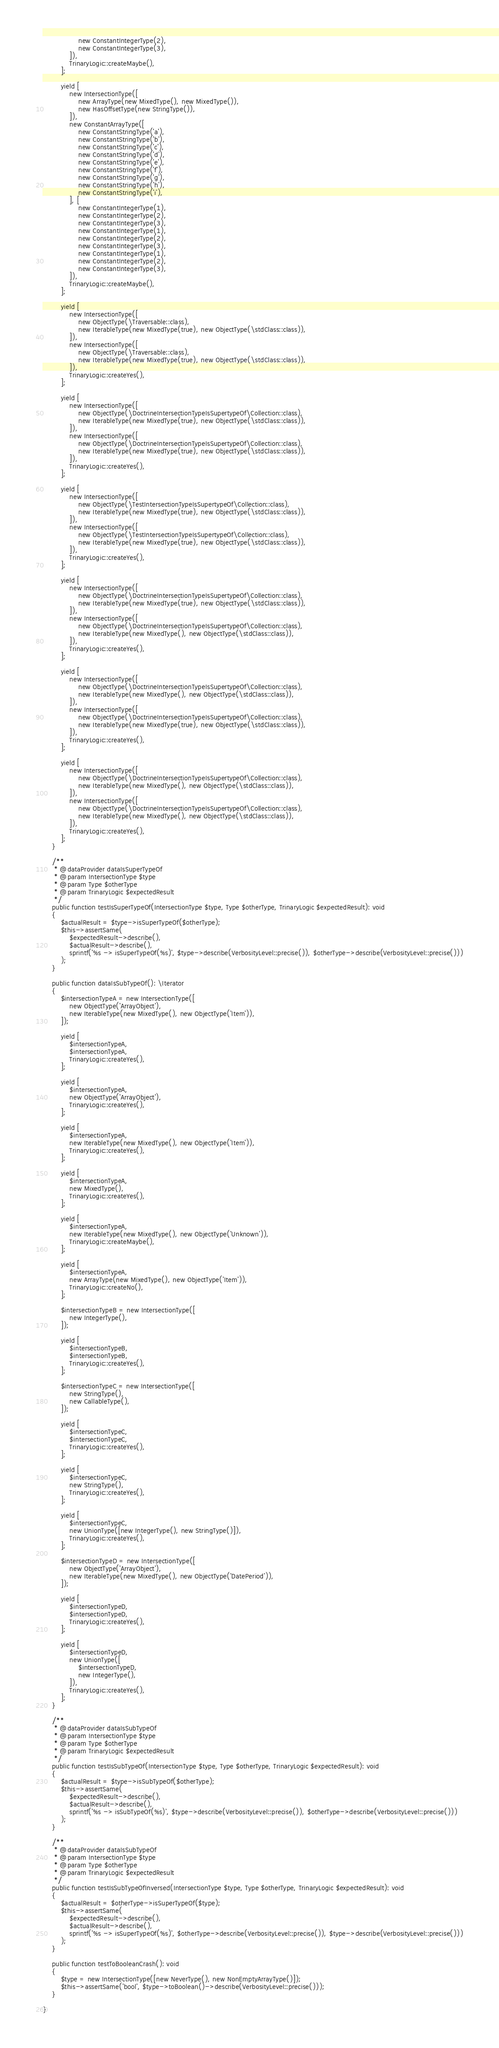Convert code to text. <code><loc_0><loc_0><loc_500><loc_500><_PHP_>				new ConstantIntegerType(2),
				new ConstantIntegerType(3),
			]),
			TrinaryLogic::createMaybe(),
		];

		yield [
			new IntersectionType([
				new ArrayType(new MixedType(), new MixedType()),
				new HasOffsetType(new StringType()),
			]),
			new ConstantArrayType([
				new ConstantStringType('a'),
				new ConstantStringType('b'),
				new ConstantStringType('c'),
				new ConstantStringType('d'),
				new ConstantStringType('e'),
				new ConstantStringType('f'),
				new ConstantStringType('g'),
				new ConstantStringType('h'),
				new ConstantStringType('i'),
			], [
				new ConstantIntegerType(1),
				new ConstantIntegerType(2),
				new ConstantIntegerType(3),
				new ConstantIntegerType(1),
				new ConstantIntegerType(2),
				new ConstantIntegerType(3),
				new ConstantIntegerType(1),
				new ConstantIntegerType(2),
				new ConstantIntegerType(3),
			]),
			TrinaryLogic::createMaybe(),
		];

		yield [
			new IntersectionType([
				new ObjectType(\Traversable::class),
				new IterableType(new MixedType(true), new ObjectType(\stdClass::class)),
			]),
			new IntersectionType([
				new ObjectType(\Traversable::class),
				new IterableType(new MixedType(true), new ObjectType(\stdClass::class)),
			]),
			TrinaryLogic::createYes(),
		];

		yield [
			new IntersectionType([
				new ObjectType(\DoctrineIntersectionTypeIsSupertypeOf\Collection::class),
				new IterableType(new MixedType(true), new ObjectType(\stdClass::class)),
			]),
			new IntersectionType([
				new ObjectType(\DoctrineIntersectionTypeIsSupertypeOf\Collection::class),
				new IterableType(new MixedType(true), new ObjectType(\stdClass::class)),
			]),
			TrinaryLogic::createYes(),
		];

		yield [
			new IntersectionType([
				new ObjectType(\TestIntersectionTypeIsSupertypeOf\Collection::class),
				new IterableType(new MixedType(true), new ObjectType(\stdClass::class)),
			]),
			new IntersectionType([
				new ObjectType(\TestIntersectionTypeIsSupertypeOf\Collection::class),
				new IterableType(new MixedType(true), new ObjectType(\stdClass::class)),
			]),
			TrinaryLogic::createYes(),
		];

		yield [
			new IntersectionType([
				new ObjectType(\DoctrineIntersectionTypeIsSupertypeOf\Collection::class),
				new IterableType(new MixedType(true), new ObjectType(\stdClass::class)),
			]),
			new IntersectionType([
				new ObjectType(\DoctrineIntersectionTypeIsSupertypeOf\Collection::class),
				new IterableType(new MixedType(), new ObjectType(\stdClass::class)),
			]),
			TrinaryLogic::createYes(),
		];

		yield [
			new IntersectionType([
				new ObjectType(\DoctrineIntersectionTypeIsSupertypeOf\Collection::class),
				new IterableType(new MixedType(), new ObjectType(\stdClass::class)),
			]),
			new IntersectionType([
				new ObjectType(\DoctrineIntersectionTypeIsSupertypeOf\Collection::class),
				new IterableType(new MixedType(true), new ObjectType(\stdClass::class)),
			]),
			TrinaryLogic::createYes(),
		];

		yield [
			new IntersectionType([
				new ObjectType(\DoctrineIntersectionTypeIsSupertypeOf\Collection::class),
				new IterableType(new MixedType(), new ObjectType(\stdClass::class)),
			]),
			new IntersectionType([
				new ObjectType(\DoctrineIntersectionTypeIsSupertypeOf\Collection::class),
				new IterableType(new MixedType(), new ObjectType(\stdClass::class)),
			]),
			TrinaryLogic::createYes(),
		];
	}

	/**
	 * @dataProvider dataIsSuperTypeOf
	 * @param IntersectionType $type
	 * @param Type $otherType
	 * @param TrinaryLogic $expectedResult
	 */
	public function testIsSuperTypeOf(IntersectionType $type, Type $otherType, TrinaryLogic $expectedResult): void
	{
		$actualResult = $type->isSuperTypeOf($otherType);
		$this->assertSame(
			$expectedResult->describe(),
			$actualResult->describe(),
			sprintf('%s -> isSuperTypeOf(%s)', $type->describe(VerbosityLevel::precise()), $otherType->describe(VerbosityLevel::precise()))
		);
	}

	public function dataIsSubTypeOf(): \Iterator
	{
		$intersectionTypeA = new IntersectionType([
			new ObjectType('ArrayObject'),
			new IterableType(new MixedType(), new ObjectType('Item')),
		]);

		yield [
			$intersectionTypeA,
			$intersectionTypeA,
			TrinaryLogic::createYes(),
		];

		yield [
			$intersectionTypeA,
			new ObjectType('ArrayObject'),
			TrinaryLogic::createYes(),
		];

		yield [
			$intersectionTypeA,
			new IterableType(new MixedType(), new ObjectType('Item')),
			TrinaryLogic::createYes(),
		];

		yield [
			$intersectionTypeA,
			new MixedType(),
			TrinaryLogic::createYes(),
		];

		yield [
			$intersectionTypeA,
			new IterableType(new MixedType(), new ObjectType('Unknown')),
			TrinaryLogic::createMaybe(),
		];

		yield [
			$intersectionTypeA,
			new ArrayType(new MixedType(), new ObjectType('Item')),
			TrinaryLogic::createNo(),
		];

		$intersectionTypeB = new IntersectionType([
			new IntegerType(),
		]);

		yield [
			$intersectionTypeB,
			$intersectionTypeB,
			TrinaryLogic::createYes(),
		];

		$intersectionTypeC = new IntersectionType([
			new StringType(),
			new CallableType(),
		]);

		yield [
			$intersectionTypeC,
			$intersectionTypeC,
			TrinaryLogic::createYes(),
		];

		yield [
			$intersectionTypeC,
			new StringType(),
			TrinaryLogic::createYes(),
		];

		yield [
			$intersectionTypeC,
			new UnionType([new IntegerType(), new StringType()]),
			TrinaryLogic::createYes(),
		];

		$intersectionTypeD = new IntersectionType([
			new ObjectType('ArrayObject'),
			new IterableType(new MixedType(), new ObjectType('DatePeriod')),
		]);

		yield [
			$intersectionTypeD,
			$intersectionTypeD,
			TrinaryLogic::createYes(),
		];

		yield [
			$intersectionTypeD,
			new UnionType([
				$intersectionTypeD,
				new IntegerType(),
			]),
			TrinaryLogic::createYes(),
		];
	}

	/**
	 * @dataProvider dataIsSubTypeOf
	 * @param IntersectionType $type
	 * @param Type $otherType
	 * @param TrinaryLogic $expectedResult
	 */
	public function testIsSubTypeOf(IntersectionType $type, Type $otherType, TrinaryLogic $expectedResult): void
	{
		$actualResult = $type->isSubTypeOf($otherType);
		$this->assertSame(
			$expectedResult->describe(),
			$actualResult->describe(),
			sprintf('%s -> isSubTypeOf(%s)', $type->describe(VerbosityLevel::precise()), $otherType->describe(VerbosityLevel::precise()))
		);
	}

	/**
	 * @dataProvider dataIsSubTypeOf
	 * @param IntersectionType $type
	 * @param Type $otherType
	 * @param TrinaryLogic $expectedResult
	 */
	public function testIsSubTypeOfInversed(IntersectionType $type, Type $otherType, TrinaryLogic $expectedResult): void
	{
		$actualResult = $otherType->isSuperTypeOf($type);
		$this->assertSame(
			$expectedResult->describe(),
			$actualResult->describe(),
			sprintf('%s -> isSuperTypeOf(%s)', $otherType->describe(VerbosityLevel::precise()), $type->describe(VerbosityLevel::precise()))
		);
	}

	public function testToBooleanCrash(): void
	{
		$type = new IntersectionType([new NeverType(), new NonEmptyArrayType()]);
		$this->assertSame('bool', $type->toBoolean()->describe(VerbosityLevel::precise()));
	}

}
</code> 